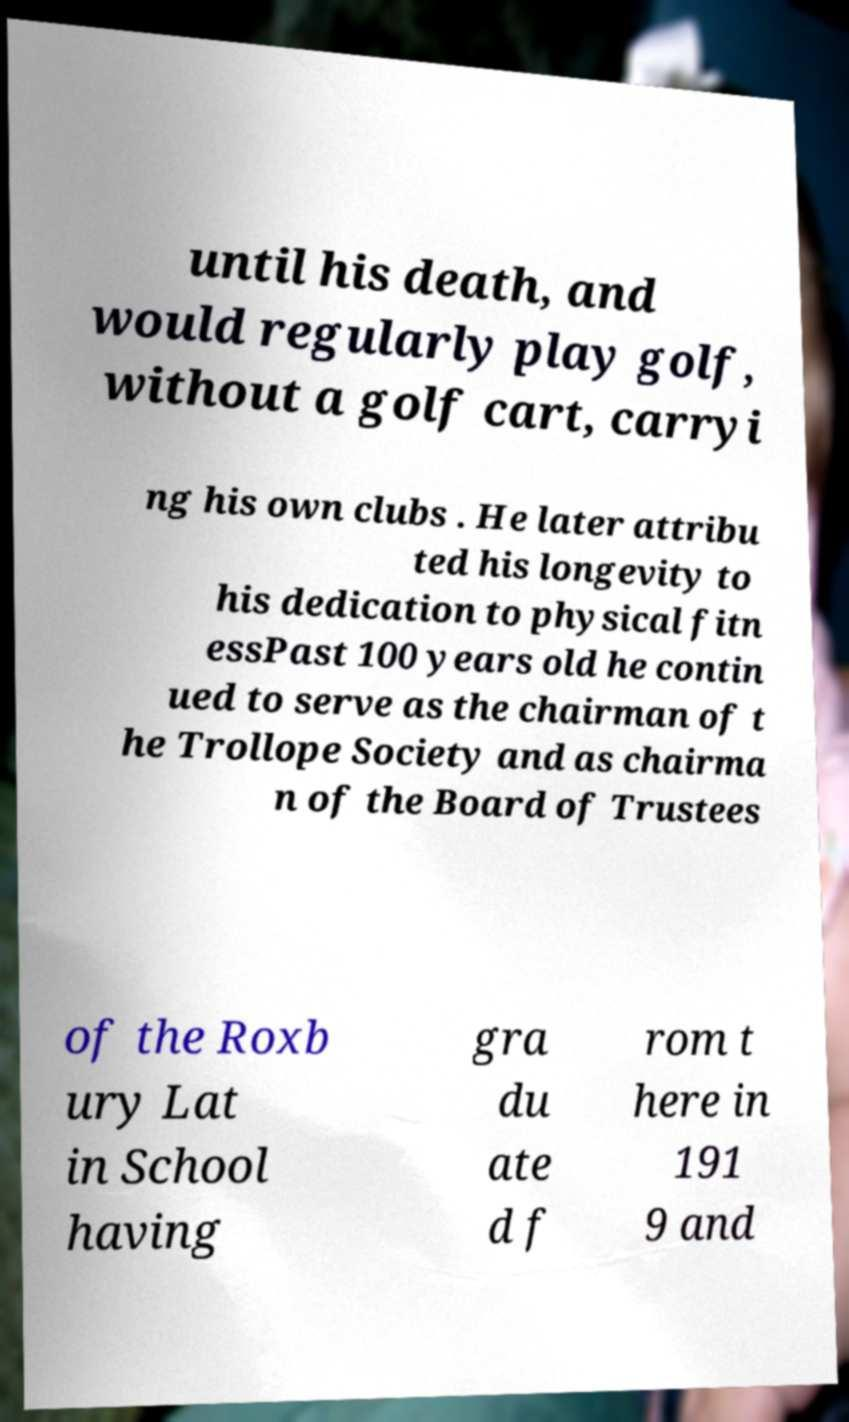For documentation purposes, I need the text within this image transcribed. Could you provide that? until his death, and would regularly play golf, without a golf cart, carryi ng his own clubs . He later attribu ted his longevity to his dedication to physical fitn essPast 100 years old he contin ued to serve as the chairman of t he Trollope Society and as chairma n of the Board of Trustees of the Roxb ury Lat in School having gra du ate d f rom t here in 191 9 and 